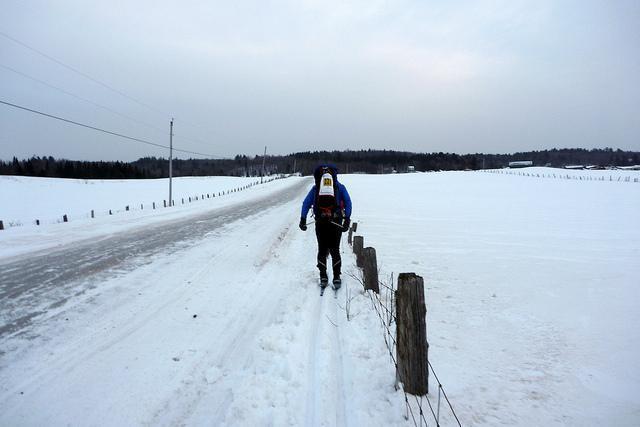How many people are there?
Give a very brief answer. 1. 